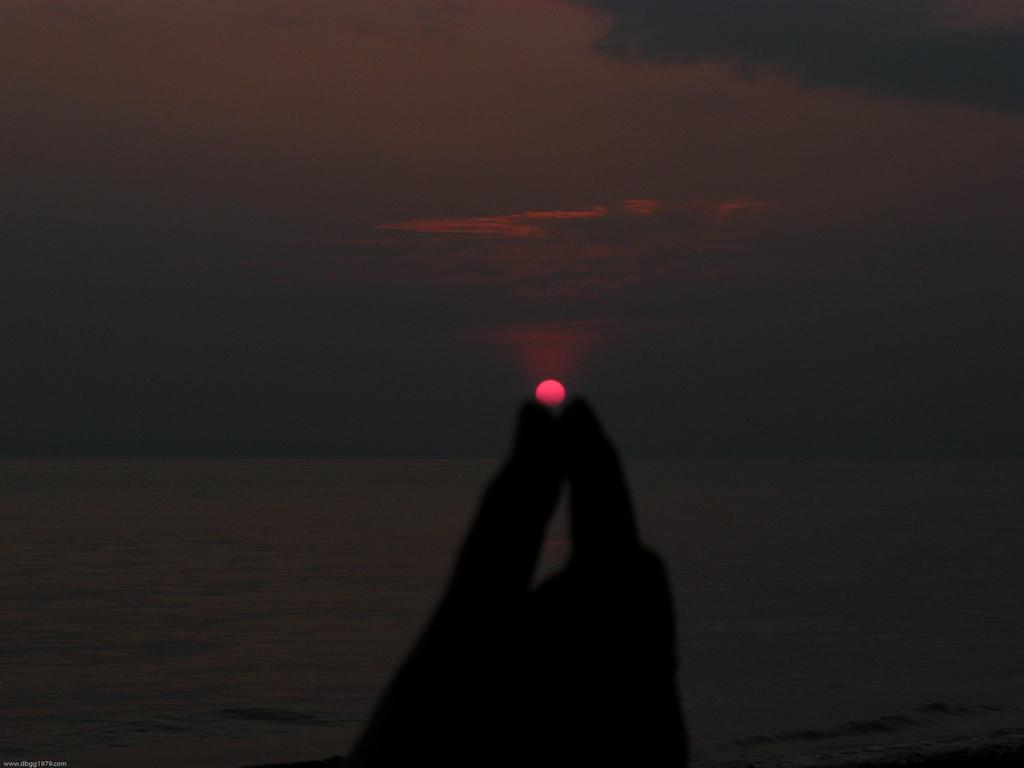What part of a person can be seen in the image? There is a hand of a person in the image. What type of natural feature is visible in the image? There is a large water body visible in the image. What celestial body is present in the image? The sun is present in the image. How would you describe the sky in the image? The sky appears cloudy in the image. What type of needle is being used on the stage in the image? There is no needle or stage present in the image; it features a hand, a large water body, the sun, and a cloudy sky. 